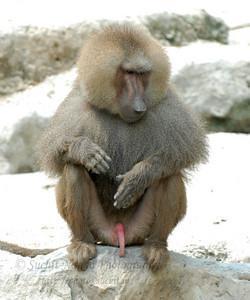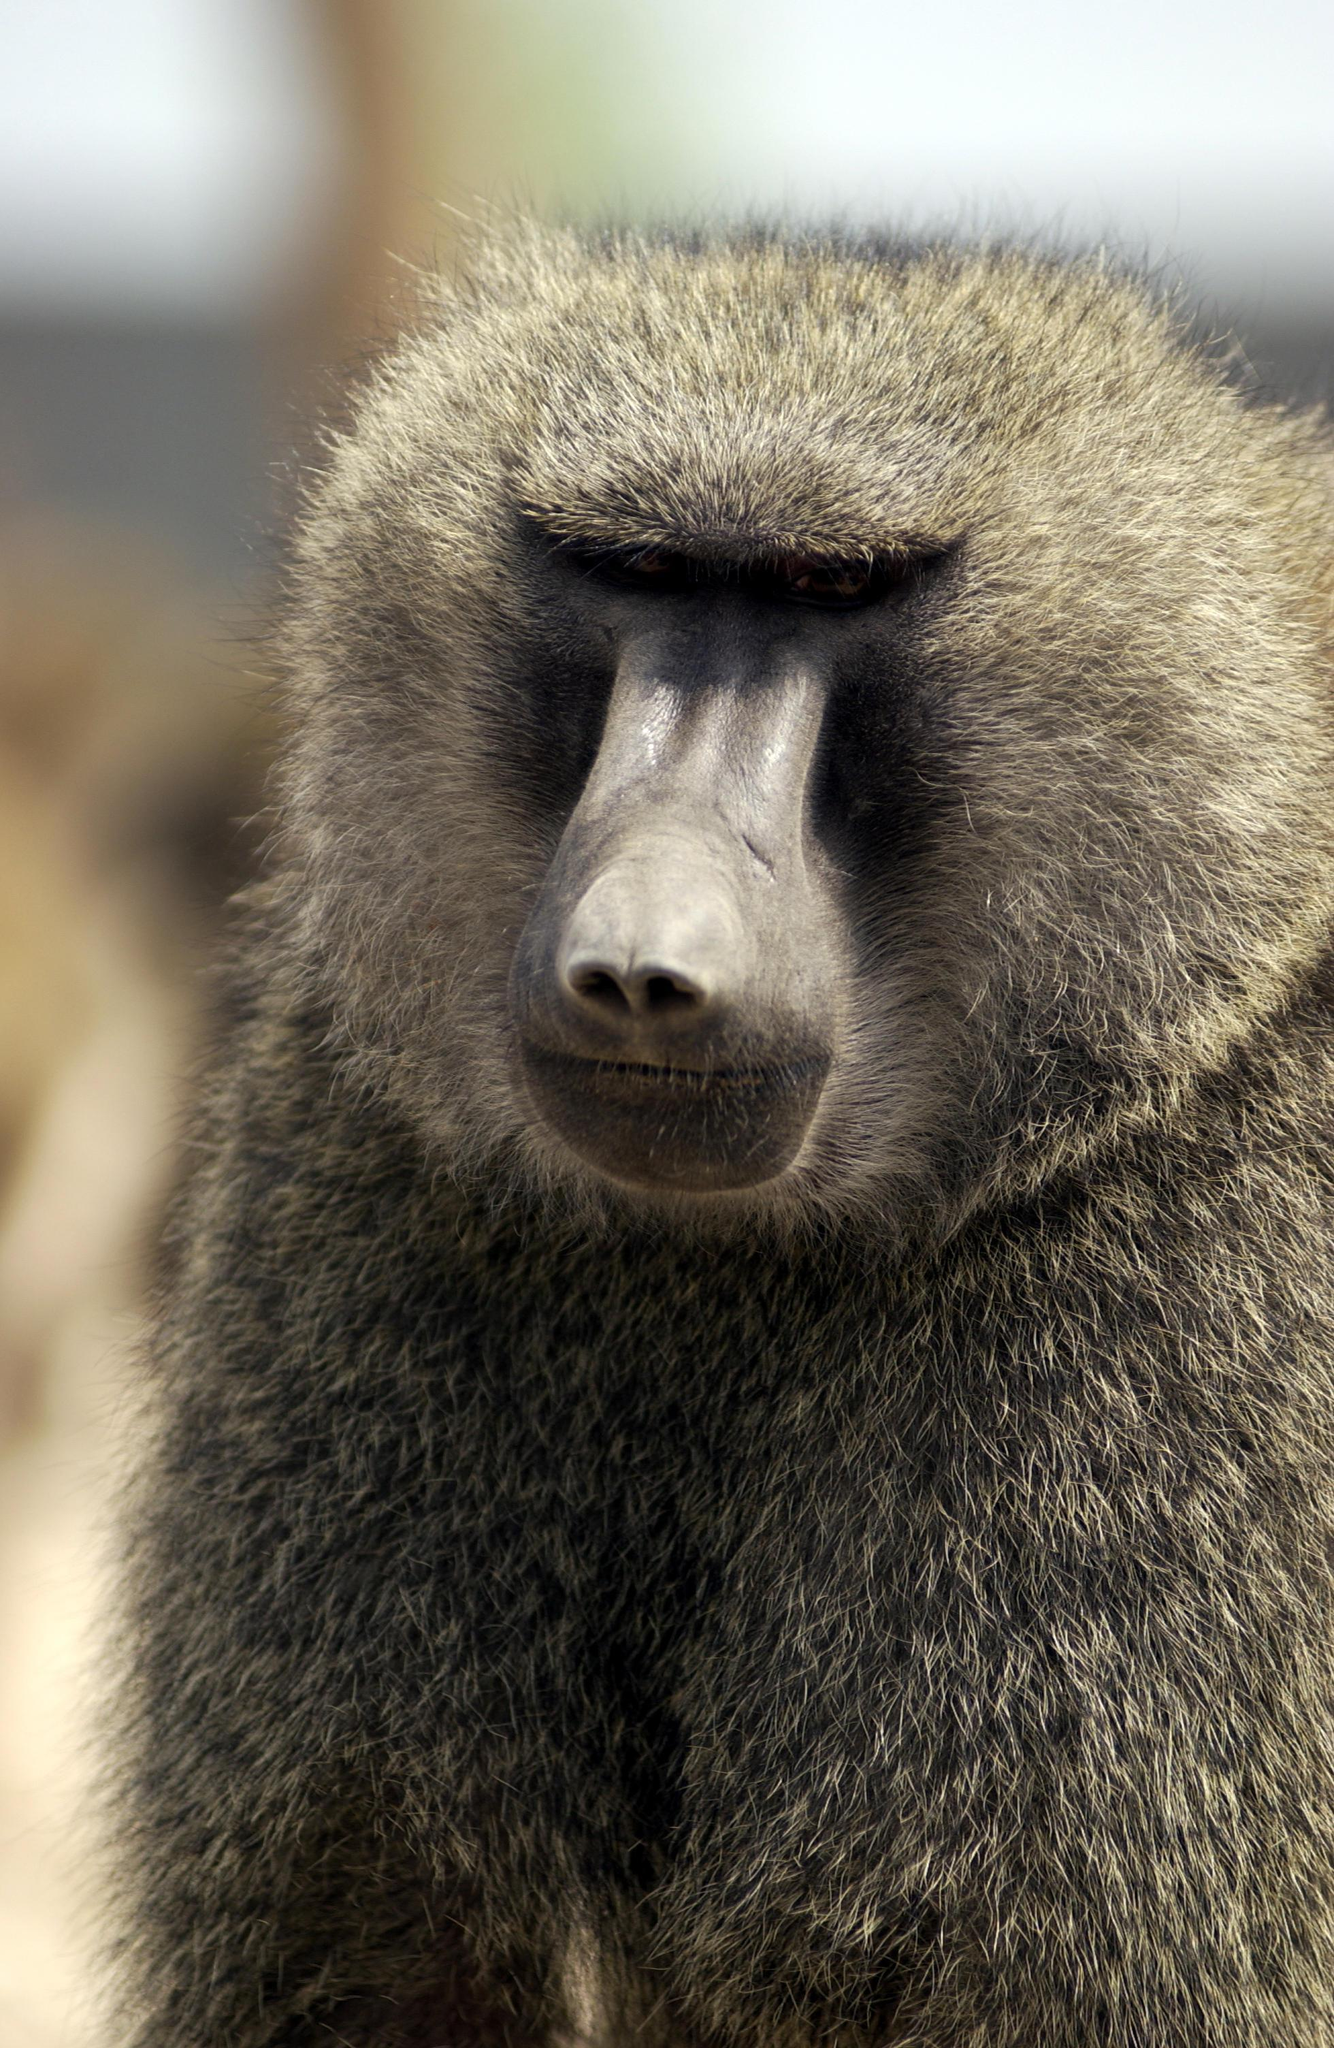The first image is the image on the left, the second image is the image on the right. For the images shown, is this caption "There are more primates in the image on the left." true? Answer yes or no. No. The first image is the image on the left, the second image is the image on the right. Given the left and right images, does the statement "The right image shows a silvery long haired monkey sitting on its pink rear, and the left image shows two monkeys with matching coloring." hold true? Answer yes or no. No. 